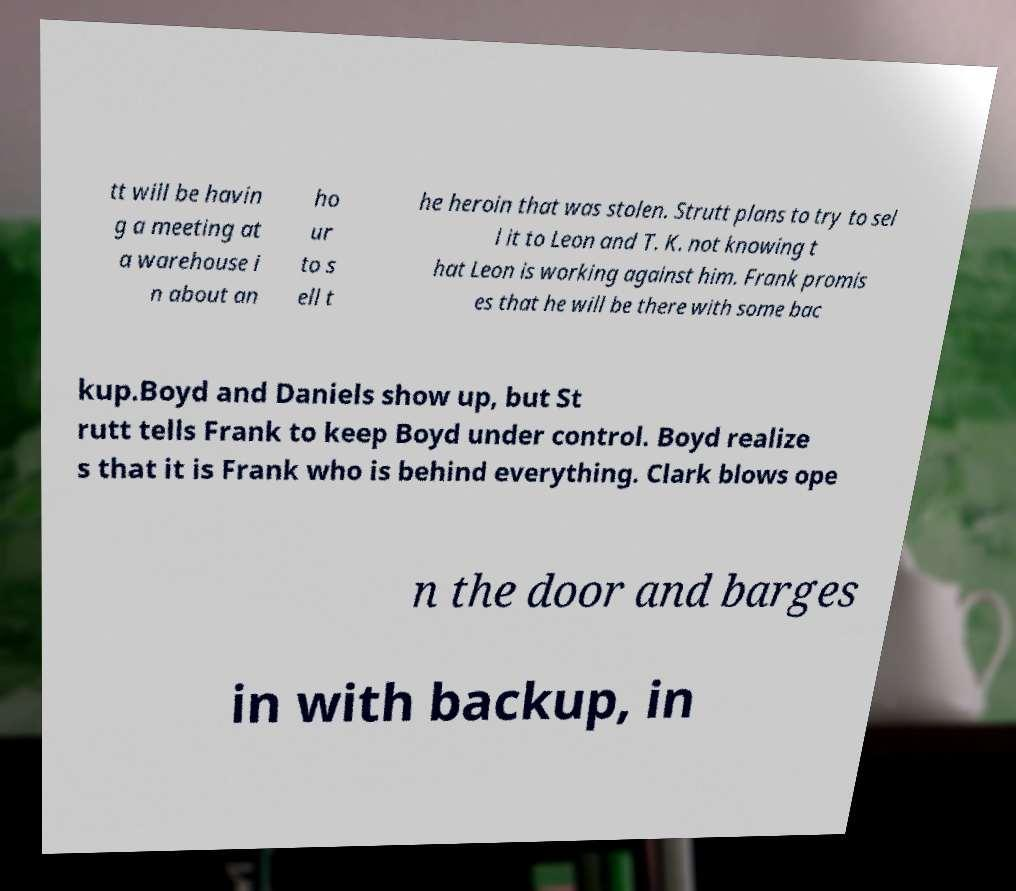For documentation purposes, I need the text within this image transcribed. Could you provide that? tt will be havin g a meeting at a warehouse i n about an ho ur to s ell t he heroin that was stolen. Strutt plans to try to sel l it to Leon and T. K. not knowing t hat Leon is working against him. Frank promis es that he will be there with some bac kup.Boyd and Daniels show up, but St rutt tells Frank to keep Boyd under control. Boyd realize s that it is Frank who is behind everything. Clark blows ope n the door and barges in with backup, in 